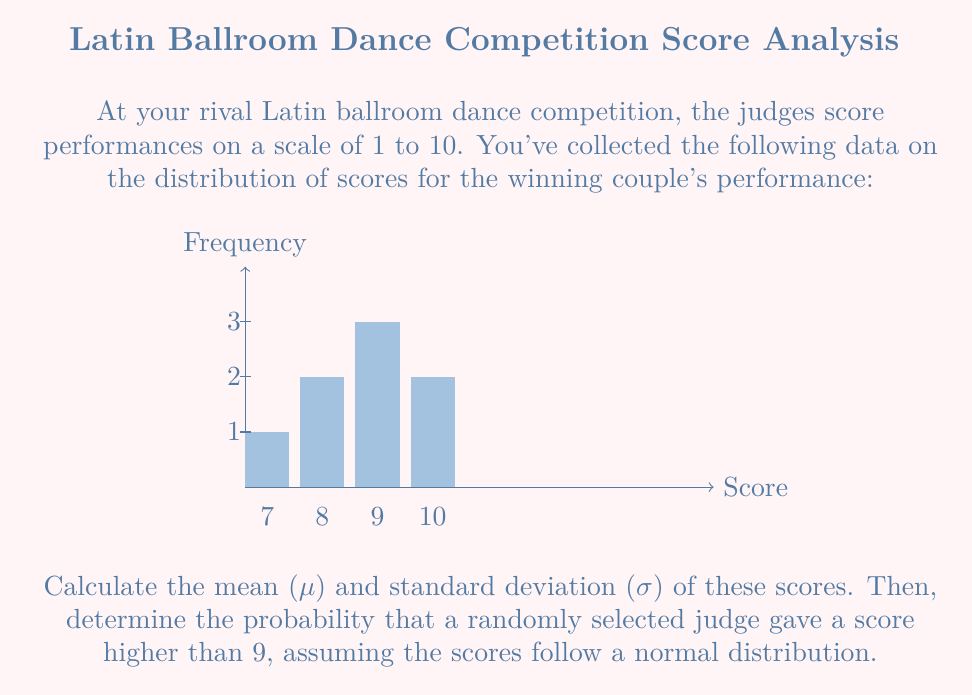Could you help me with this problem? Let's approach this step-by-step:

1) First, calculate the mean ($\mu$):
   $\mu = \frac{7(1) + 8(2) + 9(3) + 10(2)}{8} = \frac{74}{8} = 9.25$

2) To calculate the standard deviation, we need the variance first:
   $\sigma^2 = \frac{\sum_{i=1}^{n} (x_i - \mu)^2}{n}$

   $(7-9.25)^2(1) + (8-9.25)^2(2) + (9-9.25)^2(3) + (10-9.25)^2(2)$
   $= 5.0625 + 2.5312 + 0.1875 + 1.125 = 8.9062$

   $\sigma^2 = \frac{8.9062}{8} = 1.113275$

3) The standard deviation is the square root of the variance:
   $\sigma = \sqrt{1.113275} \approx 1.055$

4) To find the probability that a randomly selected judge gave a score higher than 9, we need to calculate the z-score for 9.5 (since scores are discrete):

   $z = \frac{x - \mu}{\sigma} = \frac{9.5 - 9.25}{1.055} \approx 0.237$

5) Using a standard normal distribution table or calculator, we find:
   $P(Z > 0.237) \approx 0.4063$

Therefore, the probability that a randomly selected judge gave a score higher than 9 is approximately 0.4063 or 40.63%.
Answer: $\mu \approx 9.25$, $\sigma \approx 1.055$, $P(\text{score} > 9) \approx 0.4063$ 